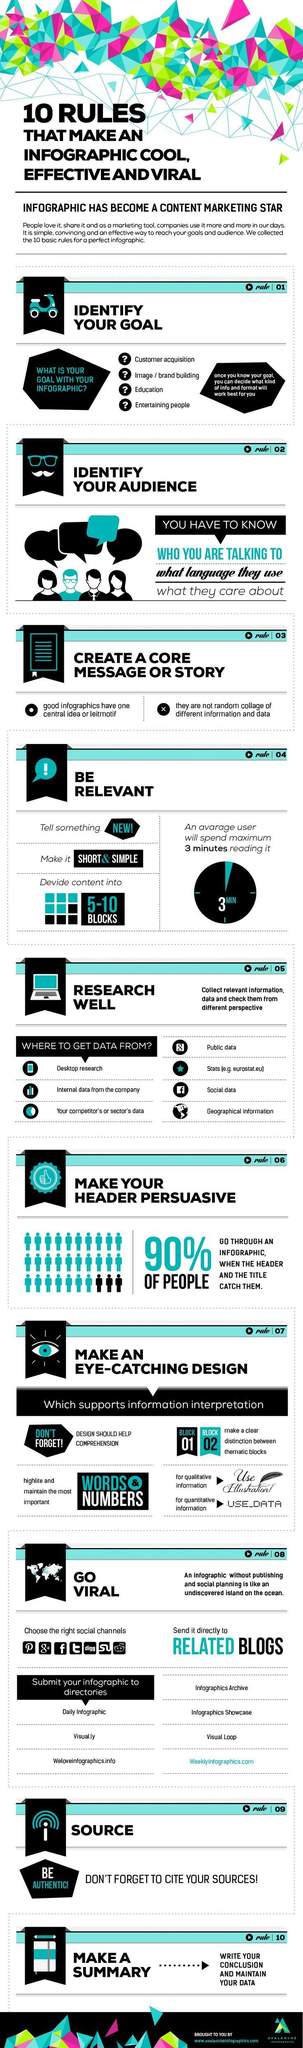Highlight a few significant elements in this photo. According to a recent study, it was found that approximately 10% of people are unlikely to engage with an infographic. The ideal number of blocks for an infographic is between 5 and 10 blocks. It is possible to collect information from up to 7 different sources. When selecting a target audience, it is important to keep the following three points in mind: 